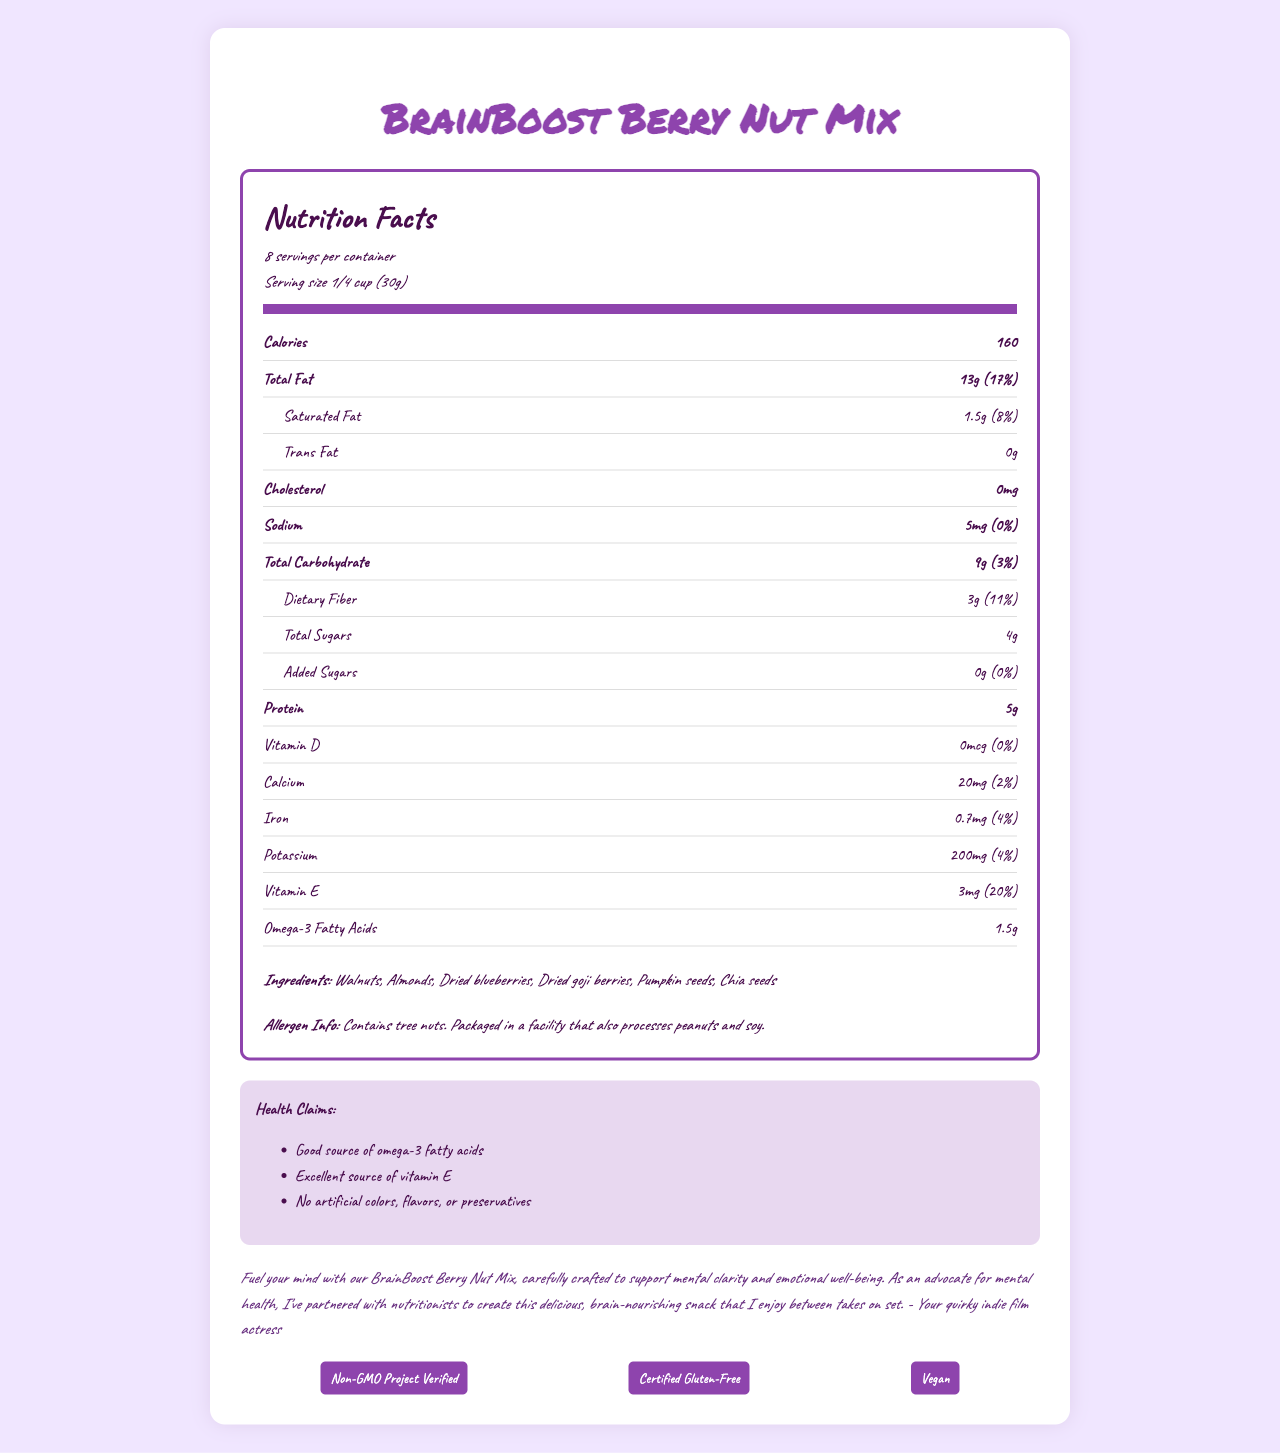what is the serving size? The serving size is clearly mentioned at the top of the Nutrition Facts section of the document.
Answer: 1/4 cup (30g) how many calories are in each serving? The "Calories" section lists the amount of calories per serving.
Answer: 160 calories which ingredient is listed first? The first ingredient listed under the "Ingredients" section is Walnuts.
Answer: Walnuts what percentage of the daily value of vitamin E does one serving provide? The "Vitamin E" section provides the amount of Vitamin E and its percentage of daily value, which is 20%.
Answer: 20% how much protein is in one serving? The "Protein" section specifies that there are 5 grams of protein per serving.
Answer: 5g what is the total amount of fat per serving? The "Total Fat" section provides this information, indicating there are 13 grams of total fat per serving.
Answer: 13g how many servings are there per container? The number of servings per container is specified at the top of the Nutrition Facts section as 8.
Answer: 8 which of these certifications does the product have? A. USDA Organic B. Non-GMO Project Verified C. Certified Kosher The certifications listed include "Non-GMO Project Verified."
Answer: B what is the total carbohydrate content per serving? The "Total Carbohydrate" section specifies the amount as 9 grams per serving.
Answer: 9g which type of fat is not present in the snack mix? A. Saturated Fat B. Trans Fat C. Omega-3 Fatty Acids The "Trans Fat" section indicates the amount is "0g," meaning there is no trans fat present in the snack mix.
Answer: B can individuals with a tree nut allergy consume this product safely? The "Allergen Info" section states that the product contains tree nuts, which means it is not safe for individuals with tree nut allergies.
Answer: No is the BrainBoost Berry Nut Mix gluten-free? The certifications section includes "Certified Gluten-Free."
Answer: Yes summarize the main purpose of the document. This document is aimed at providing comprehensive nutrition details and the key health benefits of the BrainBoost Berry Nut Mix to consumers.
Answer: The document provides detailed nutritional information for the BrainBoost Berry Nut Mix, including serving size, calories, macronutrients, vitamins, and minerals. It emphasizes that the mix is a brain-healthy snack featuring omega-3 rich nuts and antioxidant-packed berries, highlights health claims such as being a good source of omega-3 and vitamin E, lists the ingredients, mentions allergen information, and includes certifications like Non-GMO, Gluten-Free, and Vegan. what is the source of omega-3 fatty acids in the snack mix? The ingredient list includes sources like Walnuts and Chia seeds but does not specify the exact source of omega-3 fatty acids.
Answer: Not enough information what percentage of the daily value of dietary fiber is provided by one serving? The "Dietary Fiber" section indicates that one serving provides 11% of the daily value.
Answer: 11% 